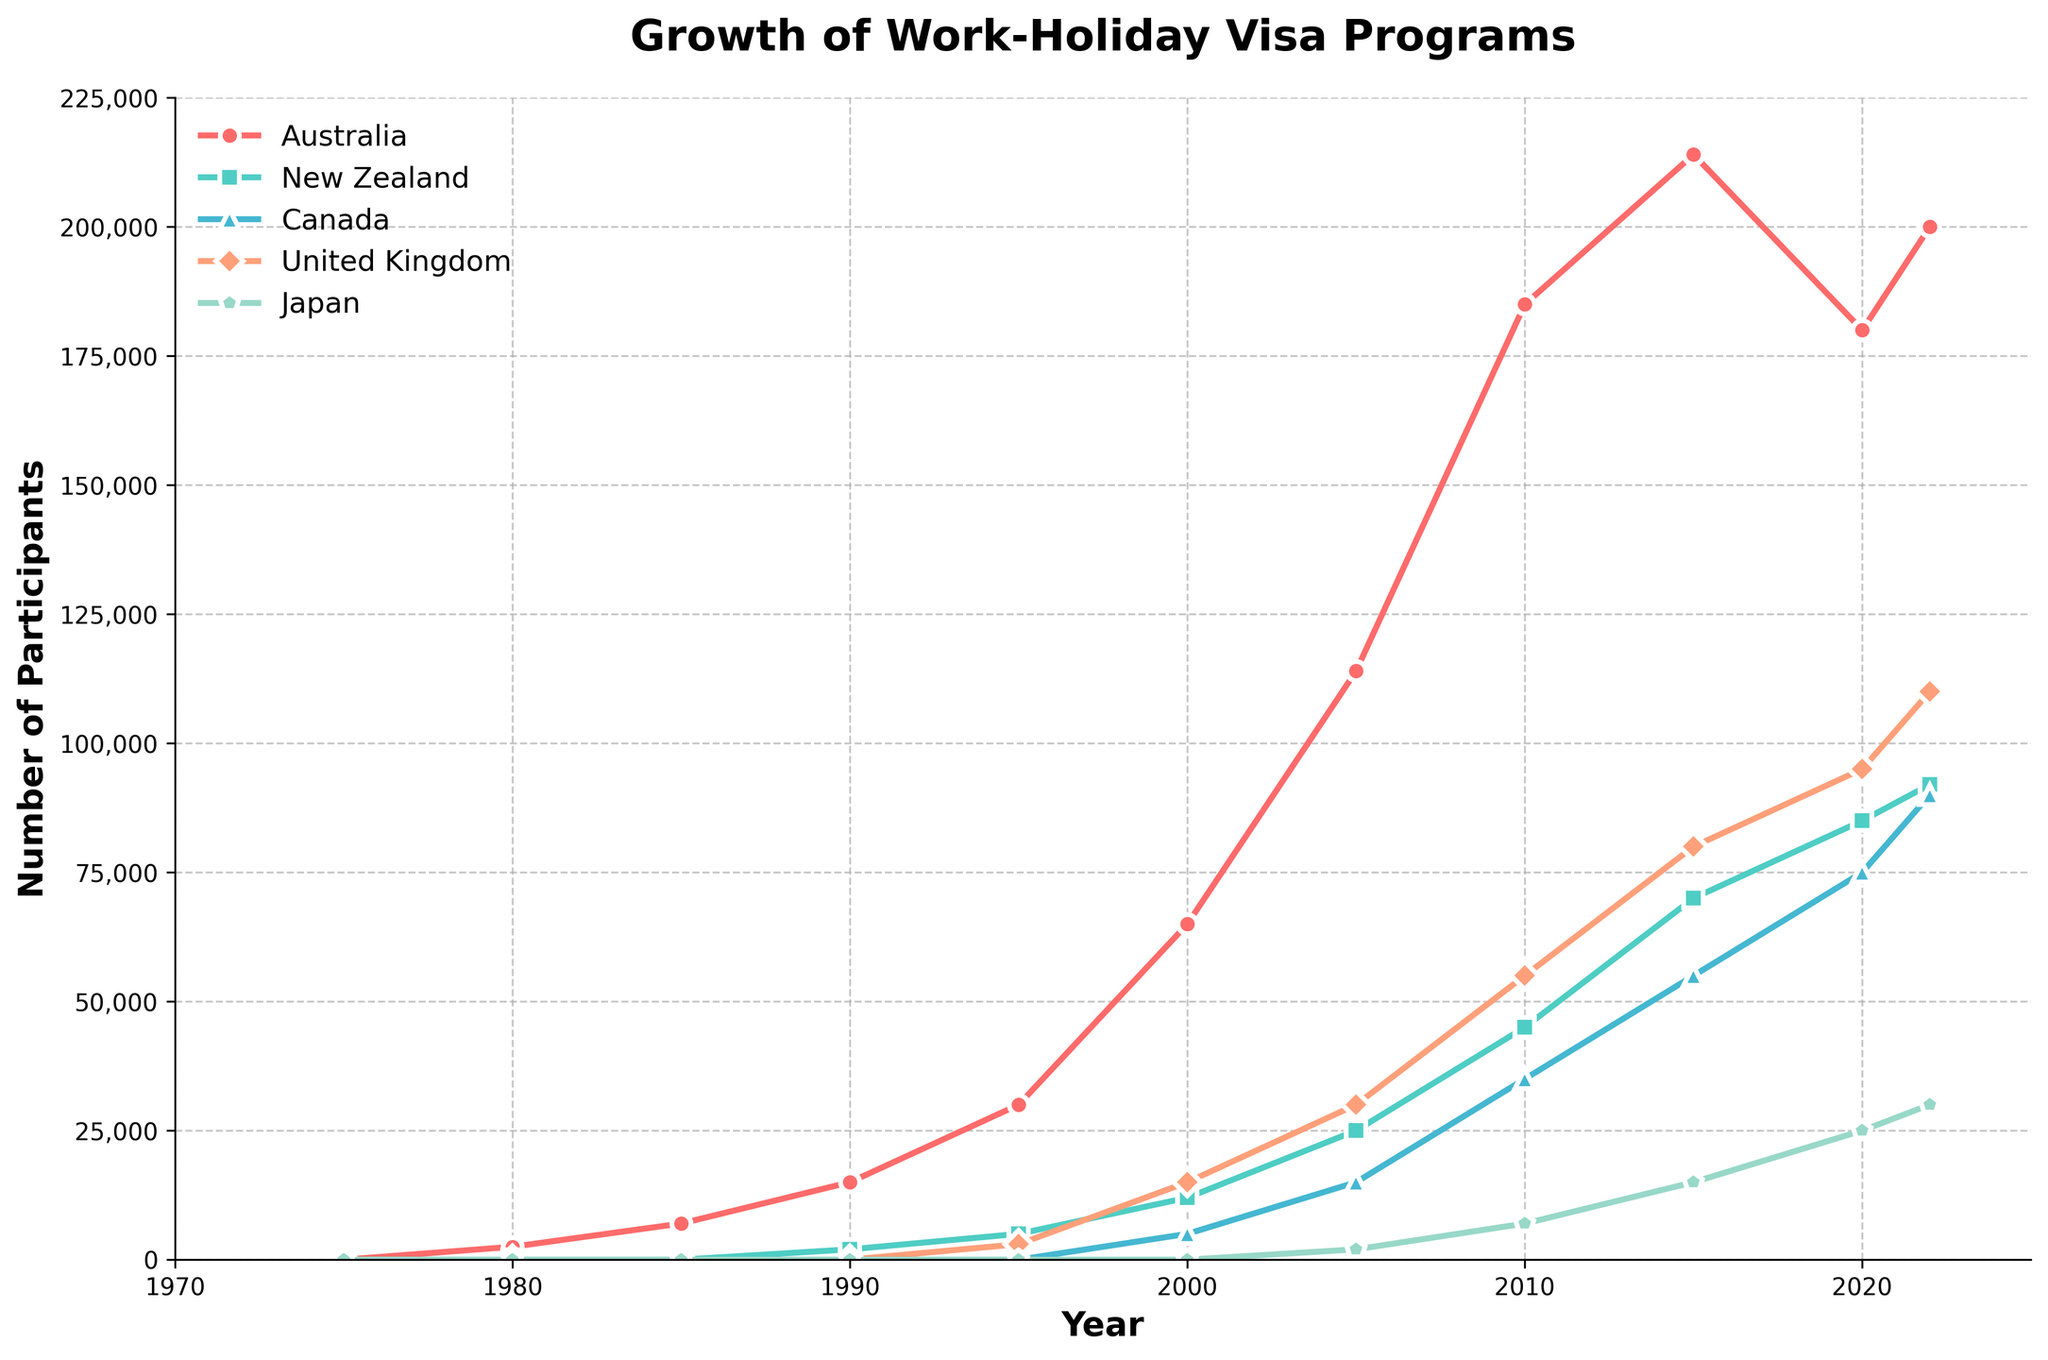What is the highest number of participants recorded in Australia? To find the highest number of participants for Australia, look for the peak value in the Australia data series. The highest value is 214,000 in 2015.
Answer: 214,000 Compare the participant numbers between Canada and the United Kingdom in 2020. Which country had more participants and by how much? First, find the participant numbers for both countries in 2020: Canada had 75,000 participants and the United Kingdom had 95,000 participants. The United Kingdom had more participants by 95,000 - 75,000 = 20,000.
Answer: The United Kingdom by 20,000 Which country shows the most consistent growth in participant numbers from 1975 to 2022? By observing the trend lines, notice that Australia shows a consistent upward trend without significant drops or plateaus from 1975 to 2022. Other countries show either late starts or less consistent growth patterns.
Answer: Australia Between 1990 and 2005, how much did the number of participants in New Zealand increase? In 1990, New Zealand had 2,000 participants and in 2005, it had 25,000 participants. The increase is 25,000 - 2,000 = 23,000.
Answer: 23,000 Identify the year when the United Kingdom reached 80,000 participants, and compare it to when Canada reached the same milestone. Which country reached this number first? The United Kingdom reached 80,000 participants in 2015. Canada also reached 80,000 participants in 2020. Therefore, the United Kingdom reached this milestone first.
Answer: The United Kingdom By how much did the number of participants in Japan increase from 2000 to 2022? In 2000, Japan had 0 participants. By 2022, Japan had 30,000 participants. The increase is 30,000 - 0 = 30,000.
Answer: 30,000 Calculate the average number of participants in Australia from 1980 to 2022. Sum the values for Australia from 1980 to 2022 and divide by the number of observations. (2,500 + 7,000 + 15,000 + 30,000 + 65,000 + 114,000 + 185,000 + 214,000 + 180,000 + 200,000) / 10 = 101,350.
Answer: 101,350 What color is used to represent New Zealand in the chart? The chart uses colors to distinguish between countries, and New Zealand is represented by the greenish-blue color line.
Answer: Greenish-blue Which two countries had the largest increase in participants from 2005 to 2010? Compare the increases for each country: Australia (71,000), New Zealand (20,000), Canada (20,000), United Kingdom (25,000), Japan (5,000). The countries with the largest increases are Australia and United Kingdom.
Answer: Australia and United Kingdom 